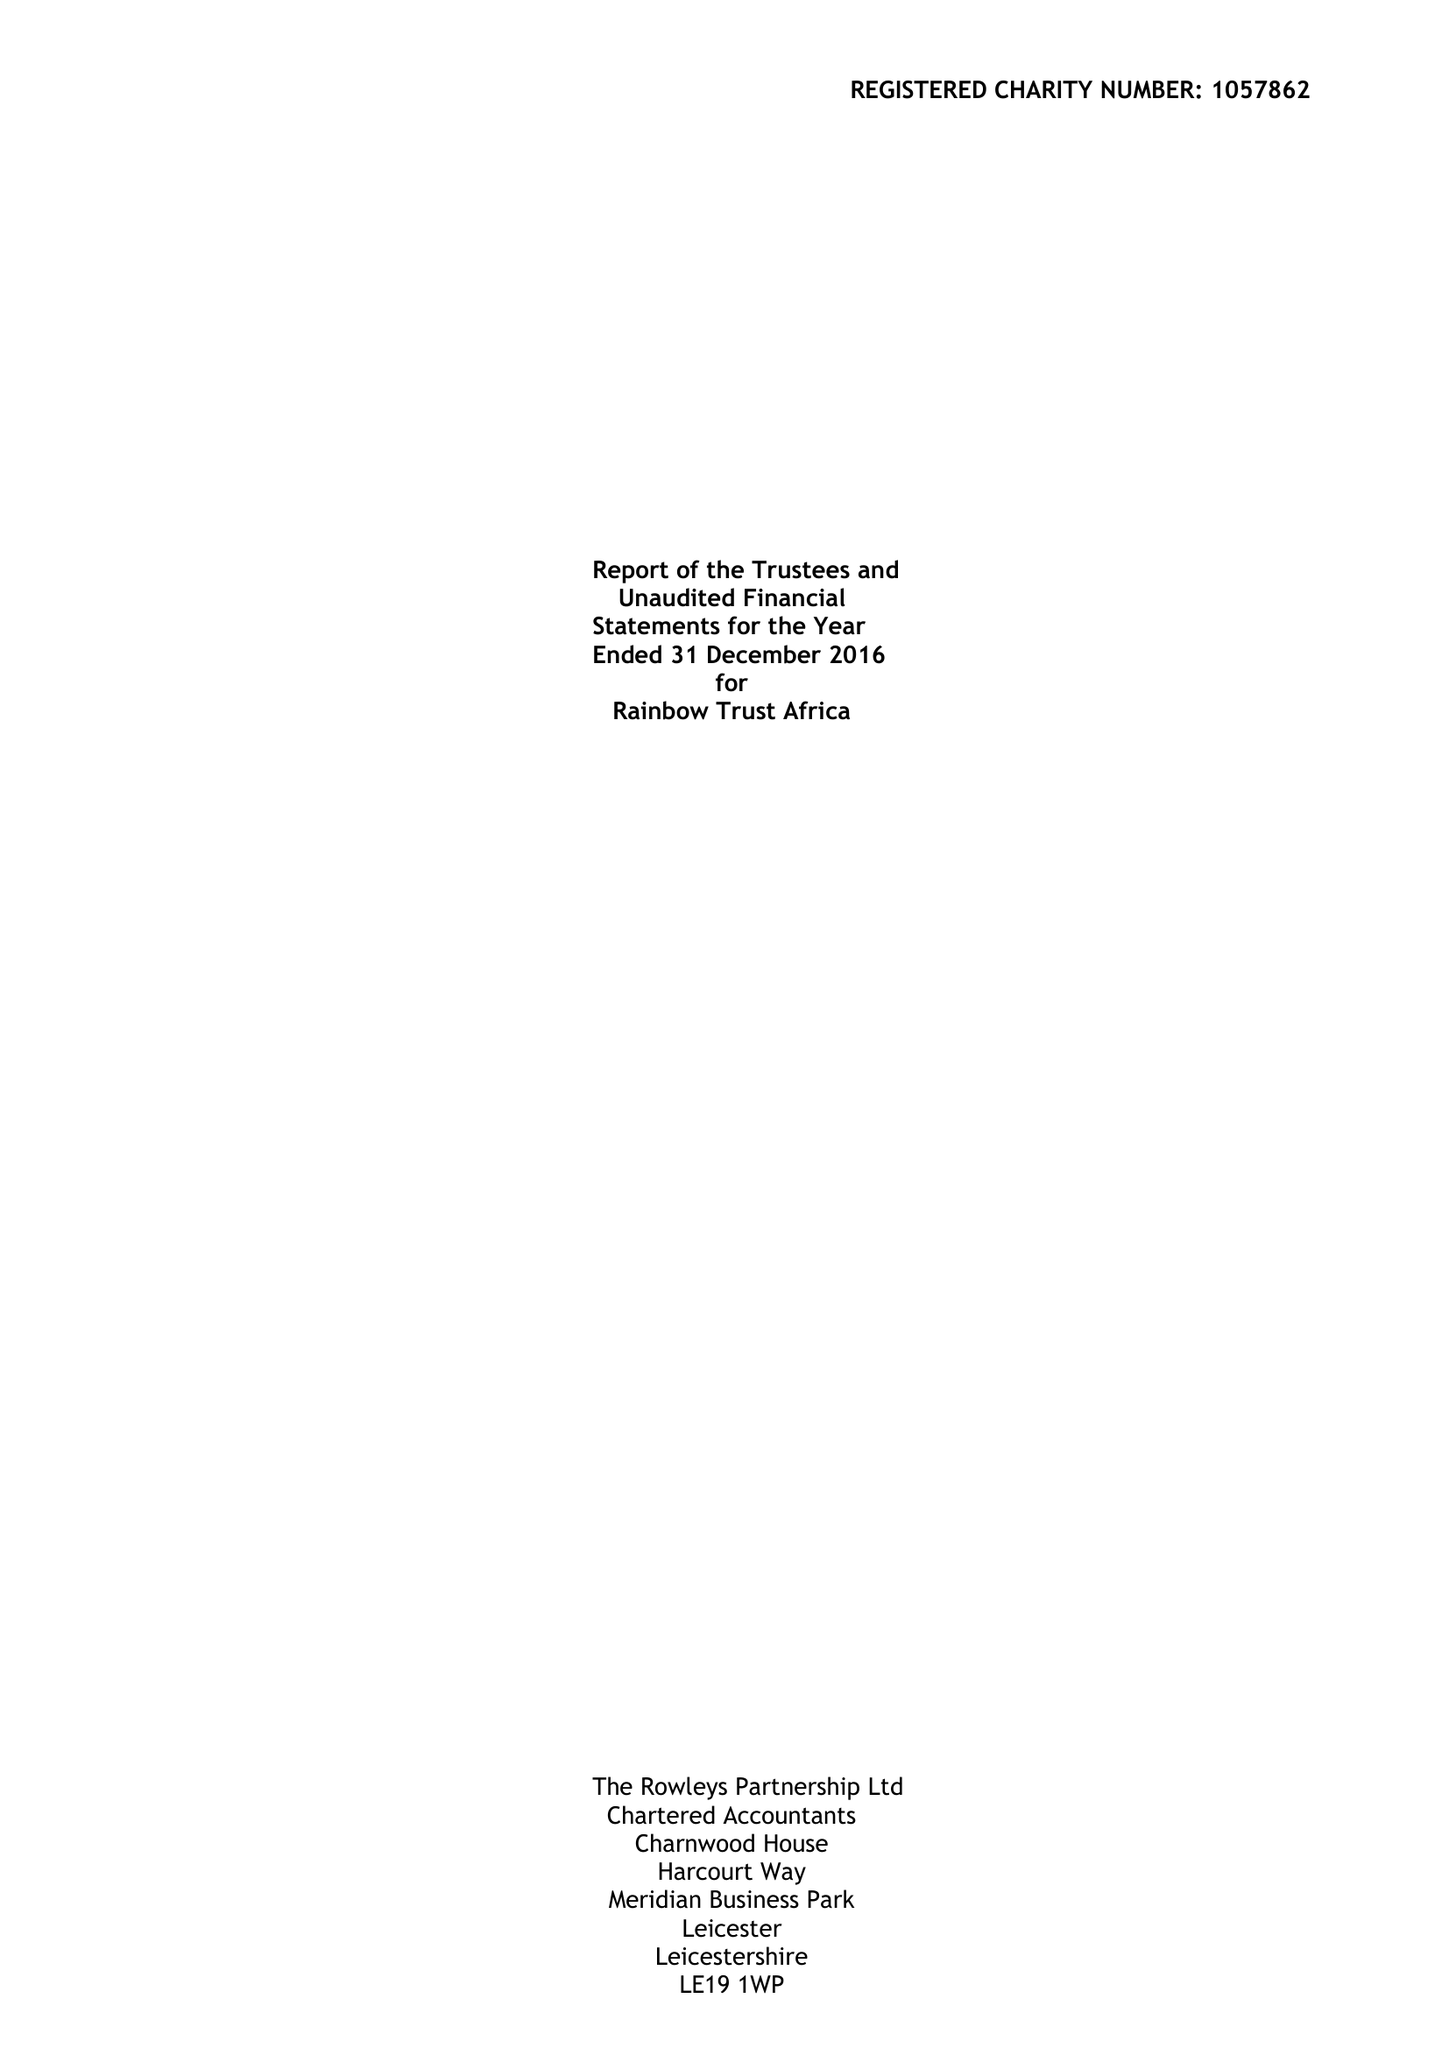What is the value for the address__post_town?
Answer the question using a single word or phrase. LEICESTER 